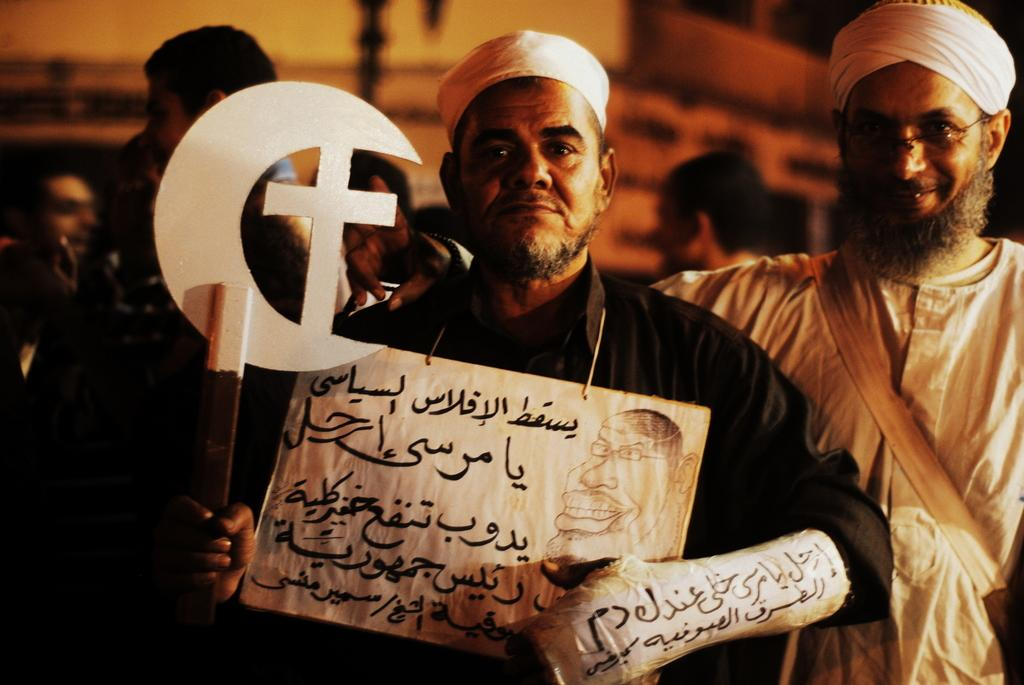Who or what can be seen in the image? There are people in the image. What are the people doing in the image? The people are standing in the image. What are the people holding in the image? The people are holding something in the image. What is the facial expression of the people in the image? The people are smiling in the image. What type of bell can be heard ringing in the image? There is no bell present or ringing in the image. What kind of soup is being served to the people in the image? There is no soup present in the image. 